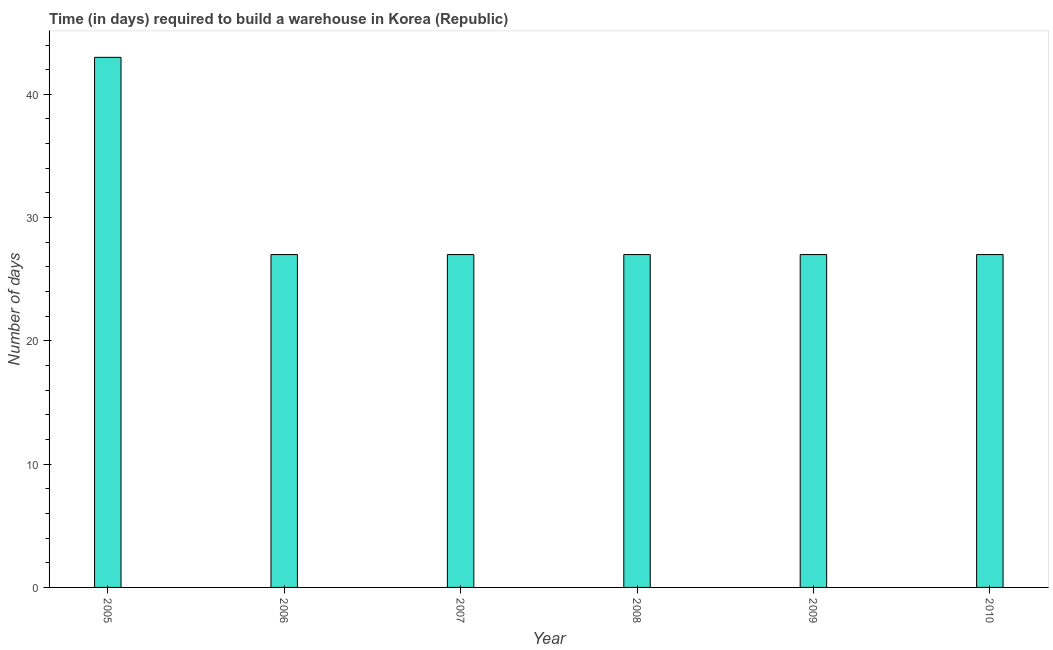What is the title of the graph?
Provide a short and direct response. Time (in days) required to build a warehouse in Korea (Republic). What is the label or title of the X-axis?
Offer a terse response. Year. What is the label or title of the Y-axis?
Your answer should be compact. Number of days. In which year was the time required to build a warehouse maximum?
Keep it short and to the point. 2005. In which year was the time required to build a warehouse minimum?
Offer a very short reply. 2006. What is the sum of the time required to build a warehouse?
Make the answer very short. 178. What is the median time required to build a warehouse?
Give a very brief answer. 27. In how many years, is the time required to build a warehouse greater than 4 days?
Offer a very short reply. 6. What is the ratio of the time required to build a warehouse in 2008 to that in 2010?
Your response must be concise. 1. Is the difference between the time required to build a warehouse in 2005 and 2008 greater than the difference between any two years?
Ensure brevity in your answer.  Yes. What is the difference between the highest and the second highest time required to build a warehouse?
Give a very brief answer. 16. In how many years, is the time required to build a warehouse greater than the average time required to build a warehouse taken over all years?
Your answer should be compact. 1. Are all the bars in the graph horizontal?
Your answer should be very brief. No. Are the values on the major ticks of Y-axis written in scientific E-notation?
Provide a short and direct response. No. What is the Number of days of 2007?
Offer a terse response. 27. What is the Number of days of 2008?
Give a very brief answer. 27. What is the difference between the Number of days in 2005 and 2006?
Provide a short and direct response. 16. What is the difference between the Number of days in 2005 and 2007?
Ensure brevity in your answer.  16. What is the difference between the Number of days in 2006 and 2007?
Your answer should be compact. 0. What is the difference between the Number of days in 2006 and 2010?
Provide a short and direct response. 0. What is the difference between the Number of days in 2007 and 2009?
Offer a terse response. 0. What is the difference between the Number of days in 2008 and 2009?
Keep it short and to the point. 0. What is the ratio of the Number of days in 2005 to that in 2006?
Your response must be concise. 1.59. What is the ratio of the Number of days in 2005 to that in 2007?
Your response must be concise. 1.59. What is the ratio of the Number of days in 2005 to that in 2008?
Your response must be concise. 1.59. What is the ratio of the Number of days in 2005 to that in 2009?
Your response must be concise. 1.59. What is the ratio of the Number of days in 2005 to that in 2010?
Make the answer very short. 1.59. What is the ratio of the Number of days in 2006 to that in 2007?
Your answer should be compact. 1. What is the ratio of the Number of days in 2006 to that in 2010?
Your response must be concise. 1. What is the ratio of the Number of days in 2007 to that in 2008?
Offer a very short reply. 1. What is the ratio of the Number of days in 2008 to that in 2009?
Provide a succinct answer. 1. 